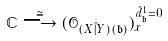<formula> <loc_0><loc_0><loc_500><loc_500>\mathbb { C } \stackrel { \cong } { \longrightarrow } ( \mathcal { O } _ { ( X \hat { | } Y ) ( \mathfrak b ) } ) ^ { \hat { d } ^ { 1 } _ { \mathfrak b } = 0 } _ { x }</formula> 